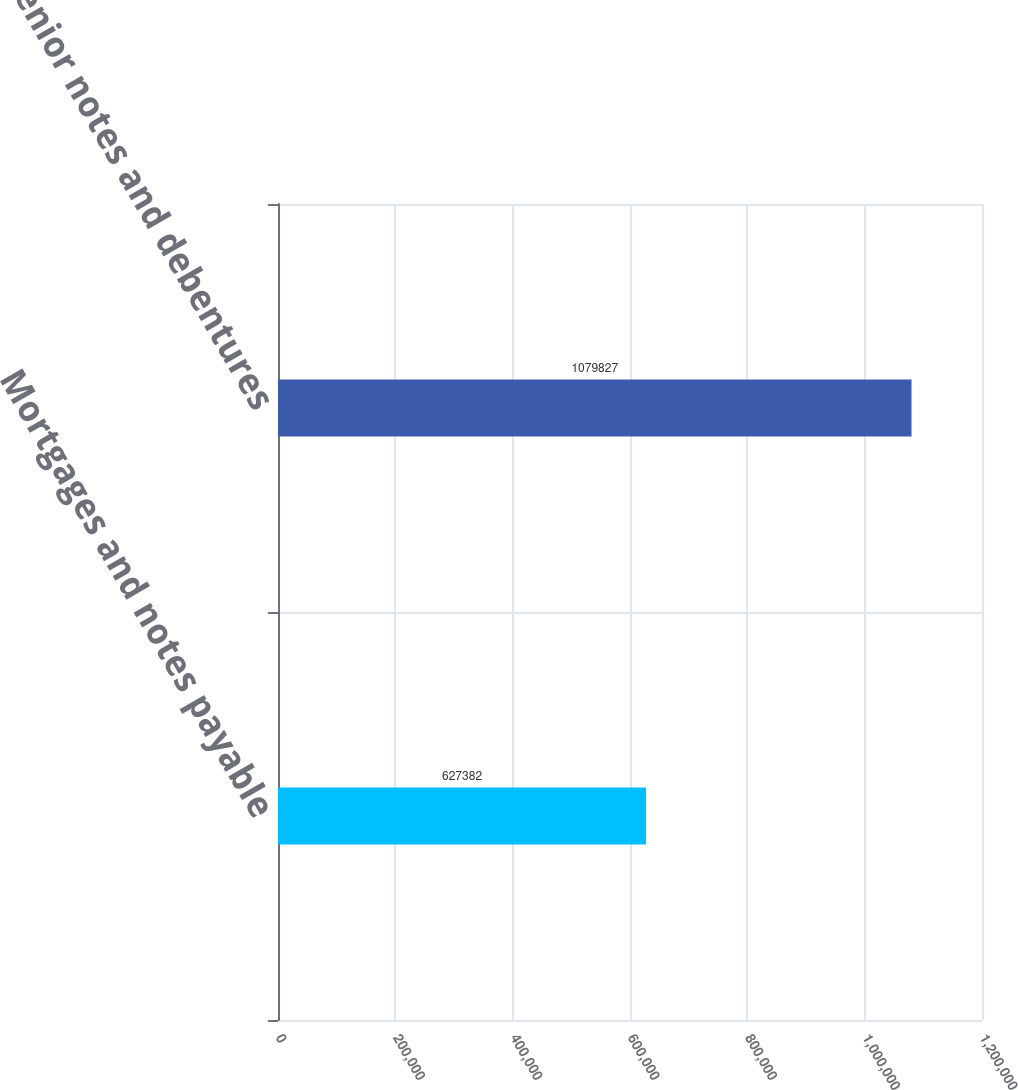Convert chart to OTSL. <chart><loc_0><loc_0><loc_500><loc_500><bar_chart><fcel>Mortgages and notes payable<fcel>Senior notes and debentures<nl><fcel>627382<fcel>1.07983e+06<nl></chart> 